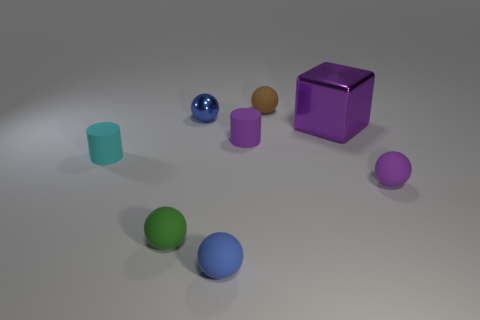What material is the other small ball that is the same color as the tiny metal sphere?
Your answer should be very brief. Rubber. Are there any other things that are the same size as the block?
Your response must be concise. No. There is a purple thing behind the small matte cylinder behind the small cyan matte cylinder; what is its size?
Make the answer very short. Large. There is a shiny thing that is the same shape as the blue rubber thing; what color is it?
Make the answer very short. Blue. Do the blue rubber sphere and the purple block have the same size?
Provide a short and direct response. No. Are there the same number of blue matte things that are right of the large shiny thing and large yellow metallic spheres?
Offer a terse response. Yes. There is a purple object that is to the left of the brown ball; are there any blue objects that are in front of it?
Ensure brevity in your answer.  Yes. There is a shiny object that is to the right of the cylinder to the right of the small sphere that is in front of the small green sphere; how big is it?
Give a very brief answer. Large. The blue ball behind the purple matte object right of the brown sphere is made of what material?
Ensure brevity in your answer.  Metal. Are there any tiny blue rubber things that have the same shape as the big metal thing?
Offer a terse response. No. 